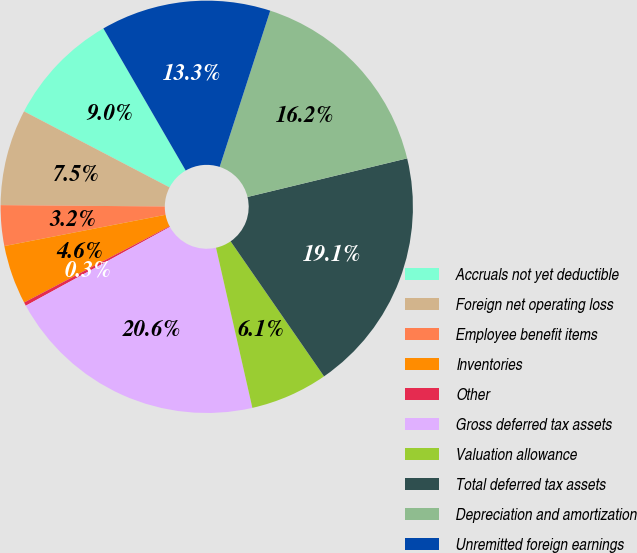<chart> <loc_0><loc_0><loc_500><loc_500><pie_chart><fcel>Accruals not yet deductible<fcel>Foreign net operating loss<fcel>Employee benefit items<fcel>Inventories<fcel>Other<fcel>Gross deferred tax assets<fcel>Valuation allowance<fcel>Total deferred tax assets<fcel>Depreciation and amortization<fcel>Unremitted foreign earnings<nl><fcel>8.98%<fcel>7.53%<fcel>3.18%<fcel>4.63%<fcel>0.28%<fcel>20.59%<fcel>6.08%<fcel>19.14%<fcel>16.24%<fcel>13.34%<nl></chart> 